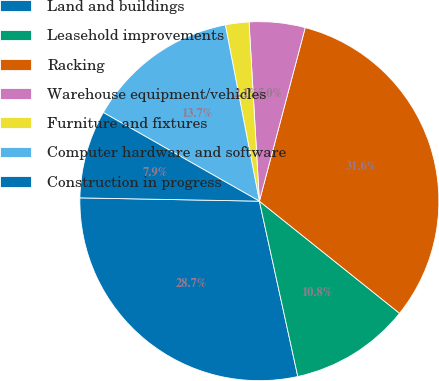Convert chart. <chart><loc_0><loc_0><loc_500><loc_500><pie_chart><fcel>Land and buildings<fcel>Leasehold improvements<fcel>Racking<fcel>Warehouse equipment/vehicles<fcel>Furniture and fixtures<fcel>Computer hardware and software<fcel>Construction in progress<nl><fcel>28.73%<fcel>10.83%<fcel>31.63%<fcel>5.03%<fcel>2.12%<fcel>13.74%<fcel>7.93%<nl></chart> 